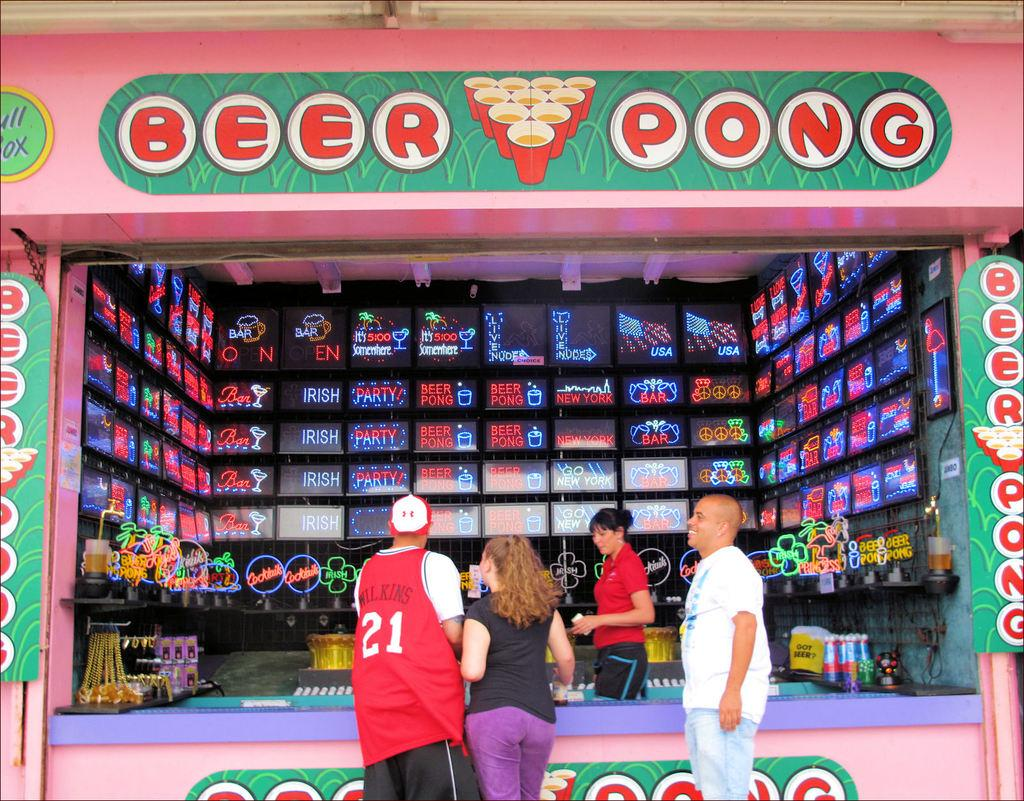<image>
Write a terse but informative summary of the picture. people playing BEER PONG at a public booth, one of the men has 21 WILKINS on the back of his shirt. 